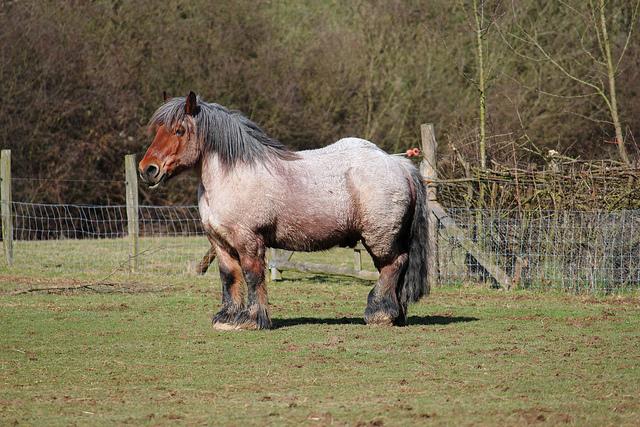What color is the horse in the background?
Keep it brief. Brown. What color is the horse's mane?
Quick response, please. Gray. Is the fence low enough for the horse to step over?
Answer briefly. No. Is this a pony?
Short answer required. Yes. What color is the fence?
Give a very brief answer. Silver. Is this horse fenced in?
Answer briefly. Yes. What species of Zebra are in the photo?
Quick response, please. Horse. 